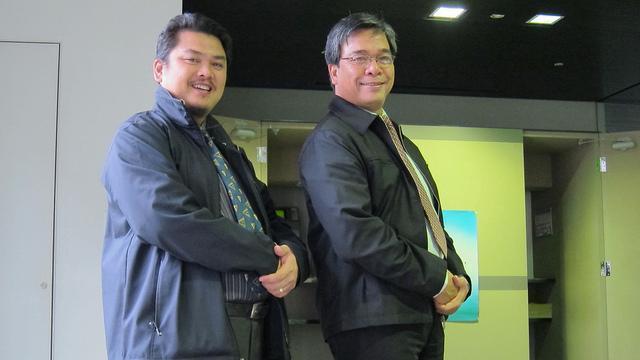How many men are dressed in black?
Give a very brief answer. 2. How many people are in the picture?
Give a very brief answer. 2. How many blue cars are in the picture?
Give a very brief answer. 0. 